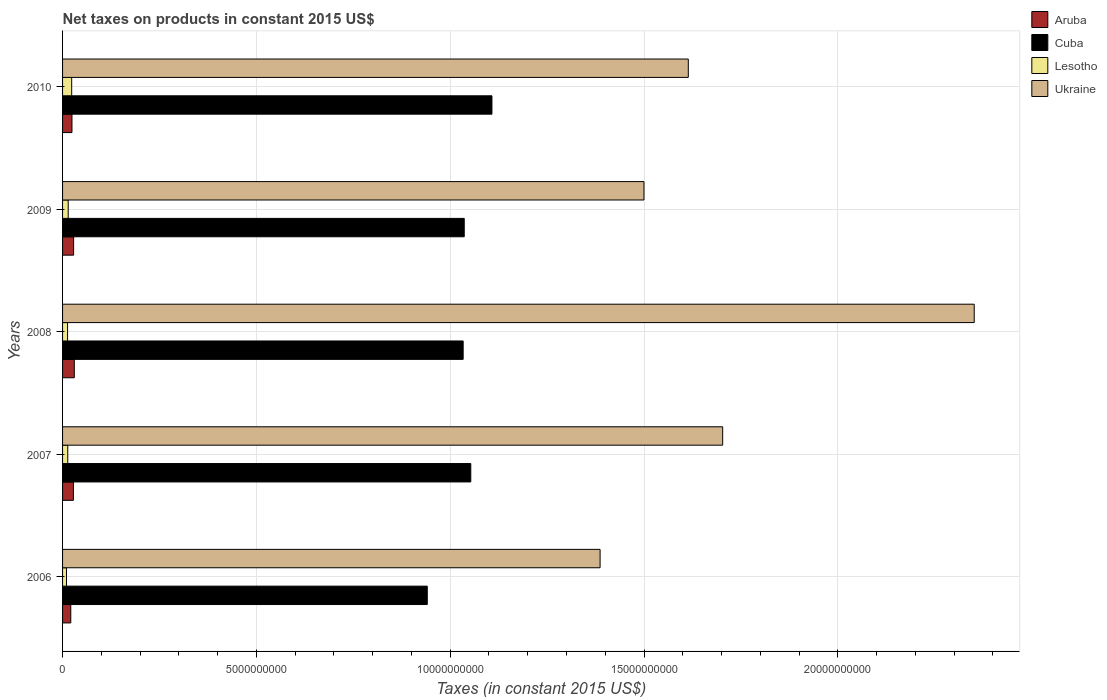How many groups of bars are there?
Offer a very short reply. 5. Are the number of bars per tick equal to the number of legend labels?
Provide a succinct answer. Yes. How many bars are there on the 5th tick from the top?
Keep it short and to the point. 4. What is the net taxes on products in Cuba in 2006?
Your answer should be very brief. 9.41e+09. Across all years, what is the maximum net taxes on products in Aruba?
Provide a short and direct response. 3.03e+08. Across all years, what is the minimum net taxes on products in Ukraine?
Your response must be concise. 1.39e+1. In which year was the net taxes on products in Ukraine minimum?
Your answer should be very brief. 2006. What is the total net taxes on products in Cuba in the graph?
Offer a very short reply. 5.17e+1. What is the difference between the net taxes on products in Aruba in 2008 and that in 2010?
Keep it short and to the point. 6.01e+07. What is the difference between the net taxes on products in Aruba in 2010 and the net taxes on products in Lesotho in 2007?
Offer a very short reply. 1.08e+08. What is the average net taxes on products in Lesotho per year?
Make the answer very short. 1.49e+08. In the year 2007, what is the difference between the net taxes on products in Ukraine and net taxes on products in Cuba?
Offer a terse response. 6.50e+09. In how many years, is the net taxes on products in Lesotho greater than 14000000000 US$?
Give a very brief answer. 0. What is the ratio of the net taxes on products in Ukraine in 2006 to that in 2008?
Make the answer very short. 0.59. Is the net taxes on products in Ukraine in 2006 less than that in 2009?
Ensure brevity in your answer.  Yes. What is the difference between the highest and the second highest net taxes on products in Ukraine?
Your answer should be very brief. 6.49e+09. What is the difference between the highest and the lowest net taxes on products in Cuba?
Provide a succinct answer. 1.67e+09. Is the sum of the net taxes on products in Cuba in 2007 and 2010 greater than the maximum net taxes on products in Lesotho across all years?
Your response must be concise. Yes. Is it the case that in every year, the sum of the net taxes on products in Lesotho and net taxes on products in Aruba is greater than the sum of net taxes on products in Ukraine and net taxes on products in Cuba?
Ensure brevity in your answer.  No. What does the 4th bar from the top in 2009 represents?
Provide a succinct answer. Aruba. What does the 3rd bar from the bottom in 2008 represents?
Offer a very short reply. Lesotho. Are all the bars in the graph horizontal?
Make the answer very short. Yes. Does the graph contain any zero values?
Offer a very short reply. No. How many legend labels are there?
Your response must be concise. 4. How are the legend labels stacked?
Offer a terse response. Vertical. What is the title of the graph?
Your answer should be compact. Net taxes on products in constant 2015 US$. What is the label or title of the X-axis?
Give a very brief answer. Taxes (in constant 2015 US$). What is the Taxes (in constant 2015 US$) in Aruba in 2006?
Offer a terse response. 2.12e+08. What is the Taxes (in constant 2015 US$) of Cuba in 2006?
Give a very brief answer. 9.41e+09. What is the Taxes (in constant 2015 US$) of Lesotho in 2006?
Keep it short and to the point. 1.01e+08. What is the Taxes (in constant 2015 US$) in Ukraine in 2006?
Offer a terse response. 1.39e+1. What is the Taxes (in constant 2015 US$) in Aruba in 2007?
Your response must be concise. 2.80e+08. What is the Taxes (in constant 2015 US$) of Cuba in 2007?
Provide a short and direct response. 1.05e+1. What is the Taxes (in constant 2015 US$) in Lesotho in 2007?
Your answer should be compact. 1.34e+08. What is the Taxes (in constant 2015 US$) in Ukraine in 2007?
Offer a very short reply. 1.70e+1. What is the Taxes (in constant 2015 US$) in Aruba in 2008?
Keep it short and to the point. 3.03e+08. What is the Taxes (in constant 2015 US$) of Cuba in 2008?
Offer a very short reply. 1.03e+1. What is the Taxes (in constant 2015 US$) in Lesotho in 2008?
Keep it short and to the point. 1.29e+08. What is the Taxes (in constant 2015 US$) of Ukraine in 2008?
Keep it short and to the point. 2.35e+1. What is the Taxes (in constant 2015 US$) of Aruba in 2009?
Offer a terse response. 2.85e+08. What is the Taxes (in constant 2015 US$) in Cuba in 2009?
Ensure brevity in your answer.  1.04e+1. What is the Taxes (in constant 2015 US$) of Lesotho in 2009?
Your answer should be very brief. 1.45e+08. What is the Taxes (in constant 2015 US$) in Ukraine in 2009?
Keep it short and to the point. 1.50e+1. What is the Taxes (in constant 2015 US$) in Aruba in 2010?
Give a very brief answer. 2.43e+08. What is the Taxes (in constant 2015 US$) in Cuba in 2010?
Offer a terse response. 1.11e+1. What is the Taxes (in constant 2015 US$) in Lesotho in 2010?
Your answer should be very brief. 2.35e+08. What is the Taxes (in constant 2015 US$) of Ukraine in 2010?
Ensure brevity in your answer.  1.61e+1. Across all years, what is the maximum Taxes (in constant 2015 US$) of Aruba?
Your response must be concise. 3.03e+08. Across all years, what is the maximum Taxes (in constant 2015 US$) in Cuba?
Give a very brief answer. 1.11e+1. Across all years, what is the maximum Taxes (in constant 2015 US$) in Lesotho?
Give a very brief answer. 2.35e+08. Across all years, what is the maximum Taxes (in constant 2015 US$) of Ukraine?
Provide a succinct answer. 2.35e+1. Across all years, what is the minimum Taxes (in constant 2015 US$) in Aruba?
Offer a terse response. 2.12e+08. Across all years, what is the minimum Taxes (in constant 2015 US$) in Cuba?
Your response must be concise. 9.41e+09. Across all years, what is the minimum Taxes (in constant 2015 US$) in Lesotho?
Provide a succinct answer. 1.01e+08. Across all years, what is the minimum Taxes (in constant 2015 US$) of Ukraine?
Offer a terse response. 1.39e+1. What is the total Taxes (in constant 2015 US$) of Aruba in the graph?
Keep it short and to the point. 1.32e+09. What is the total Taxes (in constant 2015 US$) of Cuba in the graph?
Offer a terse response. 5.17e+1. What is the total Taxes (in constant 2015 US$) of Lesotho in the graph?
Make the answer very short. 7.45e+08. What is the total Taxes (in constant 2015 US$) in Ukraine in the graph?
Offer a terse response. 8.56e+1. What is the difference between the Taxes (in constant 2015 US$) in Aruba in 2006 and that in 2007?
Offer a very short reply. -6.79e+07. What is the difference between the Taxes (in constant 2015 US$) of Cuba in 2006 and that in 2007?
Your answer should be very brief. -1.12e+09. What is the difference between the Taxes (in constant 2015 US$) in Lesotho in 2006 and that in 2007?
Your answer should be compact. -3.30e+07. What is the difference between the Taxes (in constant 2015 US$) in Ukraine in 2006 and that in 2007?
Make the answer very short. -3.16e+09. What is the difference between the Taxes (in constant 2015 US$) in Aruba in 2006 and that in 2008?
Give a very brief answer. -9.08e+07. What is the difference between the Taxes (in constant 2015 US$) in Cuba in 2006 and that in 2008?
Ensure brevity in your answer.  -9.26e+08. What is the difference between the Taxes (in constant 2015 US$) of Lesotho in 2006 and that in 2008?
Your response must be concise. -2.80e+07. What is the difference between the Taxes (in constant 2015 US$) of Ukraine in 2006 and that in 2008?
Provide a short and direct response. -9.65e+09. What is the difference between the Taxes (in constant 2015 US$) of Aruba in 2006 and that in 2009?
Provide a short and direct response. -7.34e+07. What is the difference between the Taxes (in constant 2015 US$) in Cuba in 2006 and that in 2009?
Ensure brevity in your answer.  -9.54e+08. What is the difference between the Taxes (in constant 2015 US$) in Lesotho in 2006 and that in 2009?
Keep it short and to the point. -4.42e+07. What is the difference between the Taxes (in constant 2015 US$) in Ukraine in 2006 and that in 2009?
Ensure brevity in your answer.  -1.13e+09. What is the difference between the Taxes (in constant 2015 US$) in Aruba in 2006 and that in 2010?
Provide a succinct answer. -3.07e+07. What is the difference between the Taxes (in constant 2015 US$) of Cuba in 2006 and that in 2010?
Make the answer very short. -1.67e+09. What is the difference between the Taxes (in constant 2015 US$) in Lesotho in 2006 and that in 2010?
Make the answer very short. -1.34e+08. What is the difference between the Taxes (in constant 2015 US$) in Ukraine in 2006 and that in 2010?
Offer a terse response. -2.28e+09. What is the difference between the Taxes (in constant 2015 US$) of Aruba in 2007 and that in 2008?
Your response must be concise. -2.29e+07. What is the difference between the Taxes (in constant 2015 US$) of Cuba in 2007 and that in 2008?
Give a very brief answer. 1.97e+08. What is the difference between the Taxes (in constant 2015 US$) in Lesotho in 2007 and that in 2008?
Give a very brief answer. 5.00e+06. What is the difference between the Taxes (in constant 2015 US$) of Ukraine in 2007 and that in 2008?
Provide a succinct answer. -6.49e+09. What is the difference between the Taxes (in constant 2015 US$) of Aruba in 2007 and that in 2009?
Offer a very short reply. -5.44e+06. What is the difference between the Taxes (in constant 2015 US$) in Cuba in 2007 and that in 2009?
Provide a succinct answer. 1.69e+08. What is the difference between the Taxes (in constant 2015 US$) of Lesotho in 2007 and that in 2009?
Offer a very short reply. -1.12e+07. What is the difference between the Taxes (in constant 2015 US$) of Ukraine in 2007 and that in 2009?
Offer a terse response. 2.03e+09. What is the difference between the Taxes (in constant 2015 US$) of Aruba in 2007 and that in 2010?
Your response must be concise. 3.72e+07. What is the difference between the Taxes (in constant 2015 US$) in Cuba in 2007 and that in 2010?
Your answer should be very brief. -5.46e+08. What is the difference between the Taxes (in constant 2015 US$) in Lesotho in 2007 and that in 2010?
Keep it short and to the point. -1.01e+08. What is the difference between the Taxes (in constant 2015 US$) in Ukraine in 2007 and that in 2010?
Your response must be concise. 8.87e+08. What is the difference between the Taxes (in constant 2015 US$) of Aruba in 2008 and that in 2009?
Give a very brief answer. 1.75e+07. What is the difference between the Taxes (in constant 2015 US$) of Cuba in 2008 and that in 2009?
Offer a very short reply. -2.79e+07. What is the difference between the Taxes (in constant 2015 US$) of Lesotho in 2008 and that in 2009?
Your answer should be very brief. -1.62e+07. What is the difference between the Taxes (in constant 2015 US$) of Ukraine in 2008 and that in 2009?
Make the answer very short. 8.52e+09. What is the difference between the Taxes (in constant 2015 US$) of Aruba in 2008 and that in 2010?
Provide a succinct answer. 6.01e+07. What is the difference between the Taxes (in constant 2015 US$) in Cuba in 2008 and that in 2010?
Provide a succinct answer. -7.42e+08. What is the difference between the Taxes (in constant 2015 US$) in Lesotho in 2008 and that in 2010?
Offer a terse response. -1.06e+08. What is the difference between the Taxes (in constant 2015 US$) in Ukraine in 2008 and that in 2010?
Provide a succinct answer. 7.38e+09. What is the difference between the Taxes (in constant 2015 US$) of Aruba in 2009 and that in 2010?
Your answer should be compact. 4.26e+07. What is the difference between the Taxes (in constant 2015 US$) of Cuba in 2009 and that in 2010?
Give a very brief answer. -7.15e+08. What is the difference between the Taxes (in constant 2015 US$) in Lesotho in 2009 and that in 2010?
Your answer should be compact. -9.01e+07. What is the difference between the Taxes (in constant 2015 US$) of Ukraine in 2009 and that in 2010?
Offer a terse response. -1.14e+09. What is the difference between the Taxes (in constant 2015 US$) of Aruba in 2006 and the Taxes (in constant 2015 US$) of Cuba in 2007?
Your answer should be very brief. -1.03e+1. What is the difference between the Taxes (in constant 2015 US$) in Aruba in 2006 and the Taxes (in constant 2015 US$) in Lesotho in 2007?
Your response must be concise. 7.78e+07. What is the difference between the Taxes (in constant 2015 US$) of Aruba in 2006 and the Taxes (in constant 2015 US$) of Ukraine in 2007?
Your answer should be compact. -1.68e+1. What is the difference between the Taxes (in constant 2015 US$) of Cuba in 2006 and the Taxes (in constant 2015 US$) of Lesotho in 2007?
Provide a short and direct response. 9.27e+09. What is the difference between the Taxes (in constant 2015 US$) in Cuba in 2006 and the Taxes (in constant 2015 US$) in Ukraine in 2007?
Offer a terse response. -7.62e+09. What is the difference between the Taxes (in constant 2015 US$) in Lesotho in 2006 and the Taxes (in constant 2015 US$) in Ukraine in 2007?
Give a very brief answer. -1.69e+1. What is the difference between the Taxes (in constant 2015 US$) in Aruba in 2006 and the Taxes (in constant 2015 US$) in Cuba in 2008?
Offer a terse response. -1.01e+1. What is the difference between the Taxes (in constant 2015 US$) of Aruba in 2006 and the Taxes (in constant 2015 US$) of Lesotho in 2008?
Offer a terse response. 8.28e+07. What is the difference between the Taxes (in constant 2015 US$) in Aruba in 2006 and the Taxes (in constant 2015 US$) in Ukraine in 2008?
Give a very brief answer. -2.33e+1. What is the difference between the Taxes (in constant 2015 US$) in Cuba in 2006 and the Taxes (in constant 2015 US$) in Lesotho in 2008?
Keep it short and to the point. 9.28e+09. What is the difference between the Taxes (in constant 2015 US$) in Cuba in 2006 and the Taxes (in constant 2015 US$) in Ukraine in 2008?
Make the answer very short. -1.41e+1. What is the difference between the Taxes (in constant 2015 US$) in Lesotho in 2006 and the Taxes (in constant 2015 US$) in Ukraine in 2008?
Offer a terse response. -2.34e+1. What is the difference between the Taxes (in constant 2015 US$) of Aruba in 2006 and the Taxes (in constant 2015 US$) of Cuba in 2009?
Your answer should be compact. -1.02e+1. What is the difference between the Taxes (in constant 2015 US$) in Aruba in 2006 and the Taxes (in constant 2015 US$) in Lesotho in 2009?
Your response must be concise. 6.66e+07. What is the difference between the Taxes (in constant 2015 US$) in Aruba in 2006 and the Taxes (in constant 2015 US$) in Ukraine in 2009?
Make the answer very short. -1.48e+1. What is the difference between the Taxes (in constant 2015 US$) in Cuba in 2006 and the Taxes (in constant 2015 US$) in Lesotho in 2009?
Your answer should be compact. 9.26e+09. What is the difference between the Taxes (in constant 2015 US$) in Cuba in 2006 and the Taxes (in constant 2015 US$) in Ukraine in 2009?
Offer a terse response. -5.59e+09. What is the difference between the Taxes (in constant 2015 US$) in Lesotho in 2006 and the Taxes (in constant 2015 US$) in Ukraine in 2009?
Keep it short and to the point. -1.49e+1. What is the difference between the Taxes (in constant 2015 US$) in Aruba in 2006 and the Taxes (in constant 2015 US$) in Cuba in 2010?
Offer a terse response. -1.09e+1. What is the difference between the Taxes (in constant 2015 US$) in Aruba in 2006 and the Taxes (in constant 2015 US$) in Lesotho in 2010?
Offer a terse response. -2.36e+07. What is the difference between the Taxes (in constant 2015 US$) in Aruba in 2006 and the Taxes (in constant 2015 US$) in Ukraine in 2010?
Your response must be concise. -1.59e+1. What is the difference between the Taxes (in constant 2015 US$) of Cuba in 2006 and the Taxes (in constant 2015 US$) of Lesotho in 2010?
Offer a very short reply. 9.17e+09. What is the difference between the Taxes (in constant 2015 US$) of Cuba in 2006 and the Taxes (in constant 2015 US$) of Ukraine in 2010?
Ensure brevity in your answer.  -6.73e+09. What is the difference between the Taxes (in constant 2015 US$) in Lesotho in 2006 and the Taxes (in constant 2015 US$) in Ukraine in 2010?
Ensure brevity in your answer.  -1.60e+1. What is the difference between the Taxes (in constant 2015 US$) in Aruba in 2007 and the Taxes (in constant 2015 US$) in Cuba in 2008?
Your answer should be very brief. -1.01e+1. What is the difference between the Taxes (in constant 2015 US$) of Aruba in 2007 and the Taxes (in constant 2015 US$) of Lesotho in 2008?
Give a very brief answer. 1.51e+08. What is the difference between the Taxes (in constant 2015 US$) in Aruba in 2007 and the Taxes (in constant 2015 US$) in Ukraine in 2008?
Your answer should be very brief. -2.32e+1. What is the difference between the Taxes (in constant 2015 US$) of Cuba in 2007 and the Taxes (in constant 2015 US$) of Lesotho in 2008?
Keep it short and to the point. 1.04e+1. What is the difference between the Taxes (in constant 2015 US$) of Cuba in 2007 and the Taxes (in constant 2015 US$) of Ukraine in 2008?
Give a very brief answer. -1.30e+1. What is the difference between the Taxes (in constant 2015 US$) in Lesotho in 2007 and the Taxes (in constant 2015 US$) in Ukraine in 2008?
Make the answer very short. -2.34e+1. What is the difference between the Taxes (in constant 2015 US$) in Aruba in 2007 and the Taxes (in constant 2015 US$) in Cuba in 2009?
Ensure brevity in your answer.  -1.01e+1. What is the difference between the Taxes (in constant 2015 US$) in Aruba in 2007 and the Taxes (in constant 2015 US$) in Lesotho in 2009?
Provide a succinct answer. 1.34e+08. What is the difference between the Taxes (in constant 2015 US$) in Aruba in 2007 and the Taxes (in constant 2015 US$) in Ukraine in 2009?
Make the answer very short. -1.47e+1. What is the difference between the Taxes (in constant 2015 US$) of Cuba in 2007 and the Taxes (in constant 2015 US$) of Lesotho in 2009?
Your response must be concise. 1.04e+1. What is the difference between the Taxes (in constant 2015 US$) in Cuba in 2007 and the Taxes (in constant 2015 US$) in Ukraine in 2009?
Make the answer very short. -4.47e+09. What is the difference between the Taxes (in constant 2015 US$) in Lesotho in 2007 and the Taxes (in constant 2015 US$) in Ukraine in 2009?
Make the answer very short. -1.49e+1. What is the difference between the Taxes (in constant 2015 US$) of Aruba in 2007 and the Taxes (in constant 2015 US$) of Cuba in 2010?
Give a very brief answer. -1.08e+1. What is the difference between the Taxes (in constant 2015 US$) of Aruba in 2007 and the Taxes (in constant 2015 US$) of Lesotho in 2010?
Offer a very short reply. 4.44e+07. What is the difference between the Taxes (in constant 2015 US$) in Aruba in 2007 and the Taxes (in constant 2015 US$) in Ukraine in 2010?
Provide a short and direct response. -1.59e+1. What is the difference between the Taxes (in constant 2015 US$) in Cuba in 2007 and the Taxes (in constant 2015 US$) in Lesotho in 2010?
Give a very brief answer. 1.03e+1. What is the difference between the Taxes (in constant 2015 US$) of Cuba in 2007 and the Taxes (in constant 2015 US$) of Ukraine in 2010?
Your response must be concise. -5.61e+09. What is the difference between the Taxes (in constant 2015 US$) in Lesotho in 2007 and the Taxes (in constant 2015 US$) in Ukraine in 2010?
Make the answer very short. -1.60e+1. What is the difference between the Taxes (in constant 2015 US$) of Aruba in 2008 and the Taxes (in constant 2015 US$) of Cuba in 2009?
Give a very brief answer. -1.01e+1. What is the difference between the Taxes (in constant 2015 US$) in Aruba in 2008 and the Taxes (in constant 2015 US$) in Lesotho in 2009?
Offer a very short reply. 1.57e+08. What is the difference between the Taxes (in constant 2015 US$) of Aruba in 2008 and the Taxes (in constant 2015 US$) of Ukraine in 2009?
Offer a terse response. -1.47e+1. What is the difference between the Taxes (in constant 2015 US$) in Cuba in 2008 and the Taxes (in constant 2015 US$) in Lesotho in 2009?
Offer a terse response. 1.02e+1. What is the difference between the Taxes (in constant 2015 US$) in Cuba in 2008 and the Taxes (in constant 2015 US$) in Ukraine in 2009?
Provide a succinct answer. -4.67e+09. What is the difference between the Taxes (in constant 2015 US$) of Lesotho in 2008 and the Taxes (in constant 2015 US$) of Ukraine in 2009?
Your response must be concise. -1.49e+1. What is the difference between the Taxes (in constant 2015 US$) of Aruba in 2008 and the Taxes (in constant 2015 US$) of Cuba in 2010?
Make the answer very short. -1.08e+1. What is the difference between the Taxes (in constant 2015 US$) of Aruba in 2008 and the Taxes (in constant 2015 US$) of Lesotho in 2010?
Ensure brevity in your answer.  6.72e+07. What is the difference between the Taxes (in constant 2015 US$) of Aruba in 2008 and the Taxes (in constant 2015 US$) of Ukraine in 2010?
Make the answer very short. -1.58e+1. What is the difference between the Taxes (in constant 2015 US$) of Cuba in 2008 and the Taxes (in constant 2015 US$) of Lesotho in 2010?
Offer a very short reply. 1.01e+1. What is the difference between the Taxes (in constant 2015 US$) of Cuba in 2008 and the Taxes (in constant 2015 US$) of Ukraine in 2010?
Your answer should be very brief. -5.81e+09. What is the difference between the Taxes (in constant 2015 US$) of Lesotho in 2008 and the Taxes (in constant 2015 US$) of Ukraine in 2010?
Your answer should be compact. -1.60e+1. What is the difference between the Taxes (in constant 2015 US$) in Aruba in 2009 and the Taxes (in constant 2015 US$) in Cuba in 2010?
Your response must be concise. -1.08e+1. What is the difference between the Taxes (in constant 2015 US$) of Aruba in 2009 and the Taxes (in constant 2015 US$) of Lesotho in 2010?
Your response must be concise. 4.98e+07. What is the difference between the Taxes (in constant 2015 US$) in Aruba in 2009 and the Taxes (in constant 2015 US$) in Ukraine in 2010?
Your answer should be very brief. -1.59e+1. What is the difference between the Taxes (in constant 2015 US$) of Cuba in 2009 and the Taxes (in constant 2015 US$) of Lesotho in 2010?
Your answer should be very brief. 1.01e+1. What is the difference between the Taxes (in constant 2015 US$) of Cuba in 2009 and the Taxes (in constant 2015 US$) of Ukraine in 2010?
Keep it short and to the point. -5.78e+09. What is the difference between the Taxes (in constant 2015 US$) in Lesotho in 2009 and the Taxes (in constant 2015 US$) in Ukraine in 2010?
Offer a terse response. -1.60e+1. What is the average Taxes (in constant 2015 US$) of Aruba per year?
Provide a short and direct response. 2.64e+08. What is the average Taxes (in constant 2015 US$) in Cuba per year?
Offer a very short reply. 1.03e+1. What is the average Taxes (in constant 2015 US$) in Lesotho per year?
Your answer should be compact. 1.49e+08. What is the average Taxes (in constant 2015 US$) in Ukraine per year?
Give a very brief answer. 1.71e+1. In the year 2006, what is the difference between the Taxes (in constant 2015 US$) of Aruba and Taxes (in constant 2015 US$) of Cuba?
Offer a very short reply. -9.20e+09. In the year 2006, what is the difference between the Taxes (in constant 2015 US$) of Aruba and Taxes (in constant 2015 US$) of Lesotho?
Your answer should be compact. 1.11e+08. In the year 2006, what is the difference between the Taxes (in constant 2015 US$) in Aruba and Taxes (in constant 2015 US$) in Ukraine?
Provide a short and direct response. -1.37e+1. In the year 2006, what is the difference between the Taxes (in constant 2015 US$) in Cuba and Taxes (in constant 2015 US$) in Lesotho?
Your answer should be very brief. 9.31e+09. In the year 2006, what is the difference between the Taxes (in constant 2015 US$) in Cuba and Taxes (in constant 2015 US$) in Ukraine?
Provide a short and direct response. -4.46e+09. In the year 2006, what is the difference between the Taxes (in constant 2015 US$) of Lesotho and Taxes (in constant 2015 US$) of Ukraine?
Your answer should be compact. -1.38e+1. In the year 2007, what is the difference between the Taxes (in constant 2015 US$) in Aruba and Taxes (in constant 2015 US$) in Cuba?
Your response must be concise. -1.03e+1. In the year 2007, what is the difference between the Taxes (in constant 2015 US$) in Aruba and Taxes (in constant 2015 US$) in Lesotho?
Your answer should be very brief. 1.46e+08. In the year 2007, what is the difference between the Taxes (in constant 2015 US$) of Aruba and Taxes (in constant 2015 US$) of Ukraine?
Provide a succinct answer. -1.67e+1. In the year 2007, what is the difference between the Taxes (in constant 2015 US$) of Cuba and Taxes (in constant 2015 US$) of Lesotho?
Ensure brevity in your answer.  1.04e+1. In the year 2007, what is the difference between the Taxes (in constant 2015 US$) in Cuba and Taxes (in constant 2015 US$) in Ukraine?
Keep it short and to the point. -6.50e+09. In the year 2007, what is the difference between the Taxes (in constant 2015 US$) in Lesotho and Taxes (in constant 2015 US$) in Ukraine?
Your answer should be compact. -1.69e+1. In the year 2008, what is the difference between the Taxes (in constant 2015 US$) of Aruba and Taxes (in constant 2015 US$) of Cuba?
Give a very brief answer. -1.00e+1. In the year 2008, what is the difference between the Taxes (in constant 2015 US$) of Aruba and Taxes (in constant 2015 US$) of Lesotho?
Keep it short and to the point. 1.74e+08. In the year 2008, what is the difference between the Taxes (in constant 2015 US$) in Aruba and Taxes (in constant 2015 US$) in Ukraine?
Your answer should be compact. -2.32e+1. In the year 2008, what is the difference between the Taxes (in constant 2015 US$) in Cuba and Taxes (in constant 2015 US$) in Lesotho?
Make the answer very short. 1.02e+1. In the year 2008, what is the difference between the Taxes (in constant 2015 US$) in Cuba and Taxes (in constant 2015 US$) in Ukraine?
Offer a very short reply. -1.32e+1. In the year 2008, what is the difference between the Taxes (in constant 2015 US$) of Lesotho and Taxes (in constant 2015 US$) of Ukraine?
Offer a very short reply. -2.34e+1. In the year 2009, what is the difference between the Taxes (in constant 2015 US$) in Aruba and Taxes (in constant 2015 US$) in Cuba?
Keep it short and to the point. -1.01e+1. In the year 2009, what is the difference between the Taxes (in constant 2015 US$) of Aruba and Taxes (in constant 2015 US$) of Lesotho?
Give a very brief answer. 1.40e+08. In the year 2009, what is the difference between the Taxes (in constant 2015 US$) in Aruba and Taxes (in constant 2015 US$) in Ukraine?
Your answer should be compact. -1.47e+1. In the year 2009, what is the difference between the Taxes (in constant 2015 US$) of Cuba and Taxes (in constant 2015 US$) of Lesotho?
Provide a short and direct response. 1.02e+1. In the year 2009, what is the difference between the Taxes (in constant 2015 US$) in Cuba and Taxes (in constant 2015 US$) in Ukraine?
Provide a short and direct response. -4.64e+09. In the year 2009, what is the difference between the Taxes (in constant 2015 US$) in Lesotho and Taxes (in constant 2015 US$) in Ukraine?
Your answer should be compact. -1.49e+1. In the year 2010, what is the difference between the Taxes (in constant 2015 US$) of Aruba and Taxes (in constant 2015 US$) of Cuba?
Provide a short and direct response. -1.08e+1. In the year 2010, what is the difference between the Taxes (in constant 2015 US$) of Aruba and Taxes (in constant 2015 US$) of Lesotho?
Your response must be concise. 7.16e+06. In the year 2010, what is the difference between the Taxes (in constant 2015 US$) in Aruba and Taxes (in constant 2015 US$) in Ukraine?
Provide a succinct answer. -1.59e+1. In the year 2010, what is the difference between the Taxes (in constant 2015 US$) of Cuba and Taxes (in constant 2015 US$) of Lesotho?
Offer a terse response. 1.08e+1. In the year 2010, what is the difference between the Taxes (in constant 2015 US$) in Cuba and Taxes (in constant 2015 US$) in Ukraine?
Provide a succinct answer. -5.07e+09. In the year 2010, what is the difference between the Taxes (in constant 2015 US$) in Lesotho and Taxes (in constant 2015 US$) in Ukraine?
Your answer should be very brief. -1.59e+1. What is the ratio of the Taxes (in constant 2015 US$) of Aruba in 2006 to that in 2007?
Your response must be concise. 0.76. What is the ratio of the Taxes (in constant 2015 US$) in Cuba in 2006 to that in 2007?
Give a very brief answer. 0.89. What is the ratio of the Taxes (in constant 2015 US$) of Lesotho in 2006 to that in 2007?
Your answer should be compact. 0.75. What is the ratio of the Taxes (in constant 2015 US$) of Ukraine in 2006 to that in 2007?
Your response must be concise. 0.81. What is the ratio of the Taxes (in constant 2015 US$) of Cuba in 2006 to that in 2008?
Offer a very short reply. 0.91. What is the ratio of the Taxes (in constant 2015 US$) of Lesotho in 2006 to that in 2008?
Offer a terse response. 0.78. What is the ratio of the Taxes (in constant 2015 US$) of Ukraine in 2006 to that in 2008?
Offer a terse response. 0.59. What is the ratio of the Taxes (in constant 2015 US$) of Aruba in 2006 to that in 2009?
Offer a terse response. 0.74. What is the ratio of the Taxes (in constant 2015 US$) of Cuba in 2006 to that in 2009?
Provide a short and direct response. 0.91. What is the ratio of the Taxes (in constant 2015 US$) of Lesotho in 2006 to that in 2009?
Make the answer very short. 0.7. What is the ratio of the Taxes (in constant 2015 US$) of Ukraine in 2006 to that in 2009?
Offer a very short reply. 0.92. What is the ratio of the Taxes (in constant 2015 US$) in Aruba in 2006 to that in 2010?
Offer a terse response. 0.87. What is the ratio of the Taxes (in constant 2015 US$) in Cuba in 2006 to that in 2010?
Ensure brevity in your answer.  0.85. What is the ratio of the Taxes (in constant 2015 US$) of Lesotho in 2006 to that in 2010?
Keep it short and to the point. 0.43. What is the ratio of the Taxes (in constant 2015 US$) of Ukraine in 2006 to that in 2010?
Your answer should be very brief. 0.86. What is the ratio of the Taxes (in constant 2015 US$) in Aruba in 2007 to that in 2008?
Ensure brevity in your answer.  0.92. What is the ratio of the Taxes (in constant 2015 US$) of Lesotho in 2007 to that in 2008?
Your answer should be compact. 1.04. What is the ratio of the Taxes (in constant 2015 US$) in Ukraine in 2007 to that in 2008?
Provide a succinct answer. 0.72. What is the ratio of the Taxes (in constant 2015 US$) of Aruba in 2007 to that in 2009?
Provide a succinct answer. 0.98. What is the ratio of the Taxes (in constant 2015 US$) in Cuba in 2007 to that in 2009?
Provide a succinct answer. 1.02. What is the ratio of the Taxes (in constant 2015 US$) of Lesotho in 2007 to that in 2009?
Your answer should be very brief. 0.92. What is the ratio of the Taxes (in constant 2015 US$) in Ukraine in 2007 to that in 2009?
Provide a succinct answer. 1.14. What is the ratio of the Taxes (in constant 2015 US$) of Aruba in 2007 to that in 2010?
Your answer should be compact. 1.15. What is the ratio of the Taxes (in constant 2015 US$) of Cuba in 2007 to that in 2010?
Ensure brevity in your answer.  0.95. What is the ratio of the Taxes (in constant 2015 US$) of Lesotho in 2007 to that in 2010?
Your response must be concise. 0.57. What is the ratio of the Taxes (in constant 2015 US$) of Ukraine in 2007 to that in 2010?
Keep it short and to the point. 1.05. What is the ratio of the Taxes (in constant 2015 US$) of Aruba in 2008 to that in 2009?
Provide a short and direct response. 1.06. What is the ratio of the Taxes (in constant 2015 US$) of Cuba in 2008 to that in 2009?
Give a very brief answer. 1. What is the ratio of the Taxes (in constant 2015 US$) of Lesotho in 2008 to that in 2009?
Ensure brevity in your answer.  0.89. What is the ratio of the Taxes (in constant 2015 US$) of Ukraine in 2008 to that in 2009?
Ensure brevity in your answer.  1.57. What is the ratio of the Taxes (in constant 2015 US$) in Aruba in 2008 to that in 2010?
Provide a short and direct response. 1.25. What is the ratio of the Taxes (in constant 2015 US$) in Cuba in 2008 to that in 2010?
Offer a very short reply. 0.93. What is the ratio of the Taxes (in constant 2015 US$) in Lesotho in 2008 to that in 2010?
Provide a short and direct response. 0.55. What is the ratio of the Taxes (in constant 2015 US$) of Ukraine in 2008 to that in 2010?
Provide a succinct answer. 1.46. What is the ratio of the Taxes (in constant 2015 US$) in Aruba in 2009 to that in 2010?
Provide a succinct answer. 1.18. What is the ratio of the Taxes (in constant 2015 US$) in Cuba in 2009 to that in 2010?
Keep it short and to the point. 0.94. What is the ratio of the Taxes (in constant 2015 US$) in Lesotho in 2009 to that in 2010?
Offer a very short reply. 0.62. What is the ratio of the Taxes (in constant 2015 US$) in Ukraine in 2009 to that in 2010?
Keep it short and to the point. 0.93. What is the difference between the highest and the second highest Taxes (in constant 2015 US$) in Aruba?
Keep it short and to the point. 1.75e+07. What is the difference between the highest and the second highest Taxes (in constant 2015 US$) of Cuba?
Your answer should be compact. 5.46e+08. What is the difference between the highest and the second highest Taxes (in constant 2015 US$) in Lesotho?
Offer a very short reply. 9.01e+07. What is the difference between the highest and the second highest Taxes (in constant 2015 US$) of Ukraine?
Provide a succinct answer. 6.49e+09. What is the difference between the highest and the lowest Taxes (in constant 2015 US$) in Aruba?
Make the answer very short. 9.08e+07. What is the difference between the highest and the lowest Taxes (in constant 2015 US$) in Cuba?
Give a very brief answer. 1.67e+09. What is the difference between the highest and the lowest Taxes (in constant 2015 US$) in Lesotho?
Make the answer very short. 1.34e+08. What is the difference between the highest and the lowest Taxes (in constant 2015 US$) of Ukraine?
Your response must be concise. 9.65e+09. 